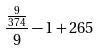<formula> <loc_0><loc_0><loc_500><loc_500>\frac { \frac { 9 } { 3 7 4 } } { 9 } - 1 + 2 6 5</formula> 